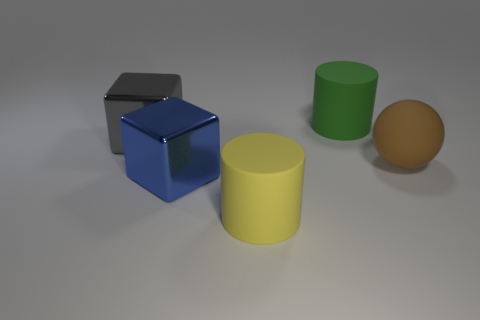Subtract all blue cubes. How many cubes are left? 1 Subtract 1 cubes. How many cubes are left? 1 Subtract all balls. How many objects are left? 4 Add 3 large brown matte balls. How many objects exist? 8 Subtract 0 blue cylinders. How many objects are left? 5 Subtract all blue spheres. Subtract all purple cubes. How many spheres are left? 1 Subtract all big green cylinders. Subtract all yellow cylinders. How many objects are left? 3 Add 2 big metal cubes. How many big metal cubes are left? 4 Add 5 blue metal objects. How many blue metal objects exist? 6 